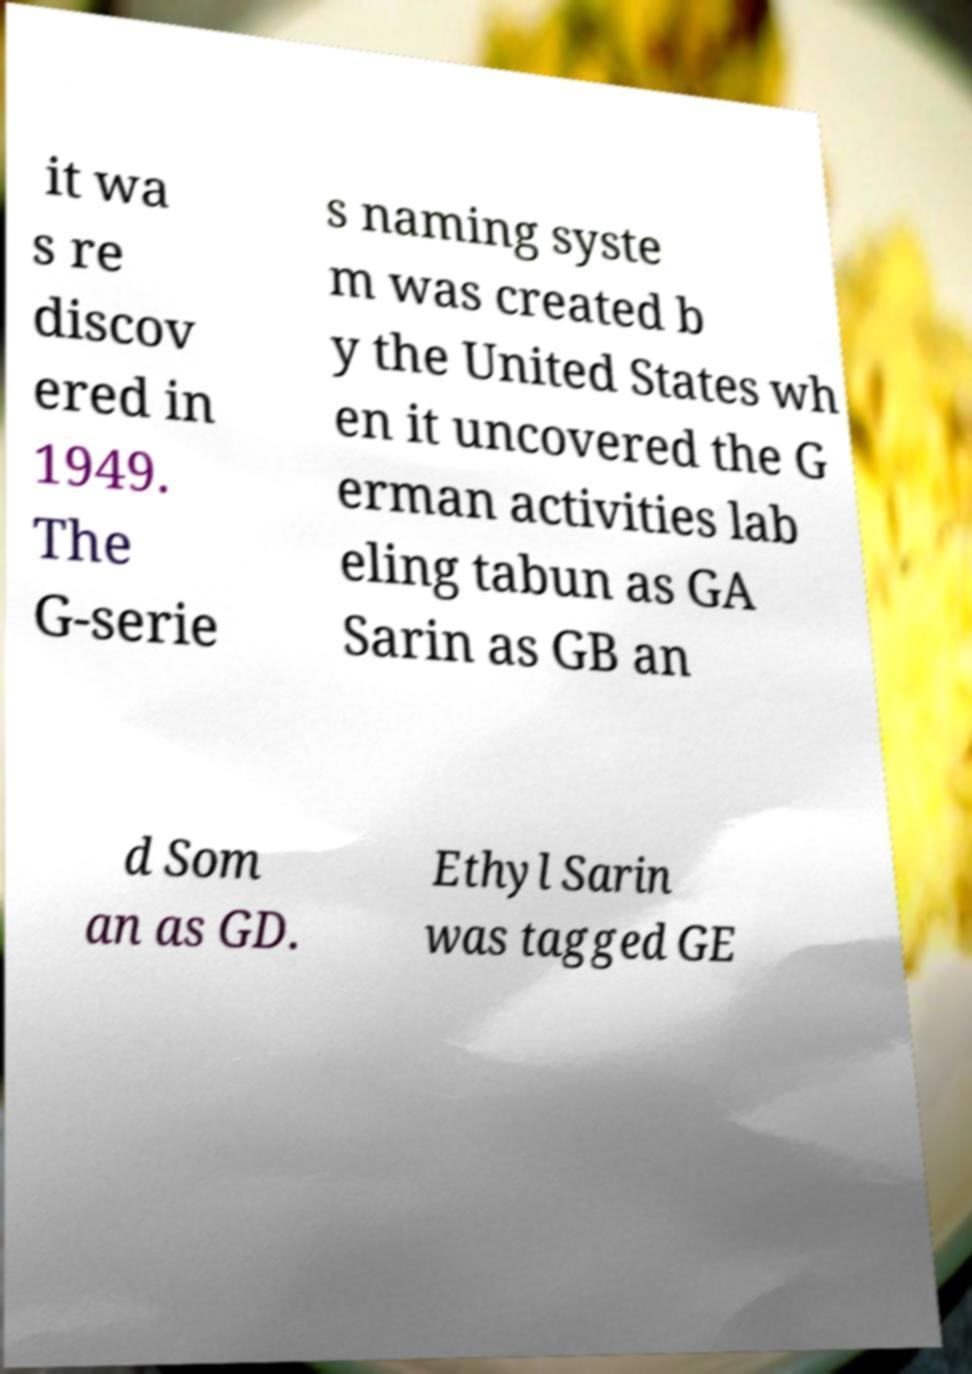There's text embedded in this image that I need extracted. Can you transcribe it verbatim? it wa s re discov ered in 1949. The G-serie s naming syste m was created b y the United States wh en it uncovered the G erman activities lab eling tabun as GA Sarin as GB an d Som an as GD. Ethyl Sarin was tagged GE 